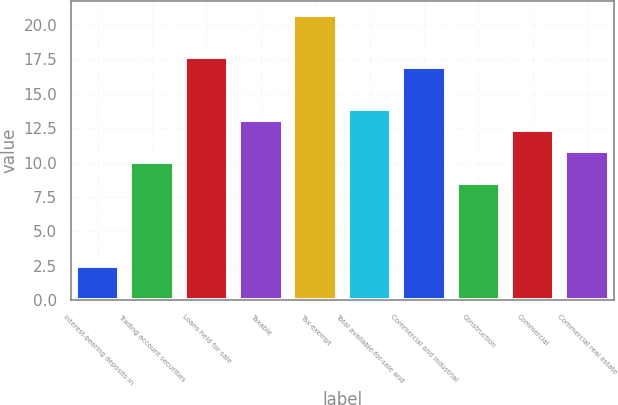Convert chart to OTSL. <chart><loc_0><loc_0><loc_500><loc_500><bar_chart><fcel>Interest-bearing deposits in<fcel>Trading account securities<fcel>Loans held for sale<fcel>Taxable<fcel>Tax-exempt<fcel>Total available-for-sale and<fcel>Commercial and industrial<fcel>Construction<fcel>Commercial<fcel>Commercial real estate<nl><fcel>2.47<fcel>10.07<fcel>17.67<fcel>13.11<fcel>20.71<fcel>13.87<fcel>16.91<fcel>8.55<fcel>12.35<fcel>10.83<nl></chart> 